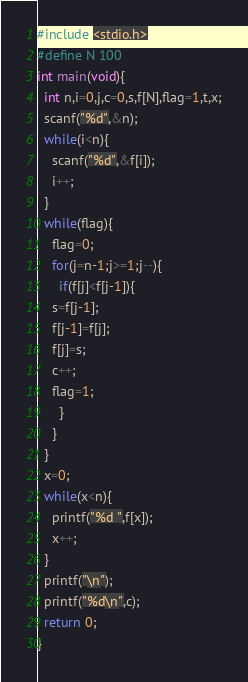<code> <loc_0><loc_0><loc_500><loc_500><_C_>#include <stdio.h>
#define N 100
int main(void){
  int n,i=0,j,c=0,s,f[N],flag=1,t,x;
  scanf("%d",&n);
  while(i<n){
    scanf("%d",&f[i]);
    i++;
  }
  while(flag){
    flag=0;
    for(j=n-1;j>=1;j--){
      if(f[j]<f[j-1]){
	s=f[j-1];
	f[j-1]=f[j];
	f[j]=s;
	c++;
	flag=1;
      }
    }
  }
  x=0;
  while(x<n){
    printf("%d ",f[x]);
    x++;
  }
  printf("\n");
  printf("%d\n",c);
  return 0;
}

</code> 